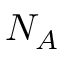<formula> <loc_0><loc_0><loc_500><loc_500>N _ { A }</formula> 